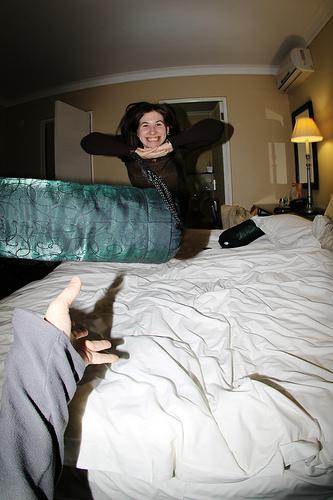Question: what is behind the person with the clasped hands?
Choices:
A. A closed window.
B. A hog dog stand.
C. An open doorway.
D. A child.
Answer with the letter. Answer: C Question: how many hands are visible?
Choices:
A. Six.
B. Two.
C. One.
D. Three.
Answer with the letter. Answer: D Question: where is the white ceiling?
Choices:
A. At the top.
B. Behind the people.
C. Next to the brown ceiling.
D. Above the person with the clasped hands.
Answer with the letter. Answer: D Question: why is the person with the clasped hands grinning?
Choices:
A. They are welcoming tourists.
B. They are a greeter at a retail store.
C. They are smiling for the camera.
D. They are happy to see people.
Answer with the letter. Answer: C 